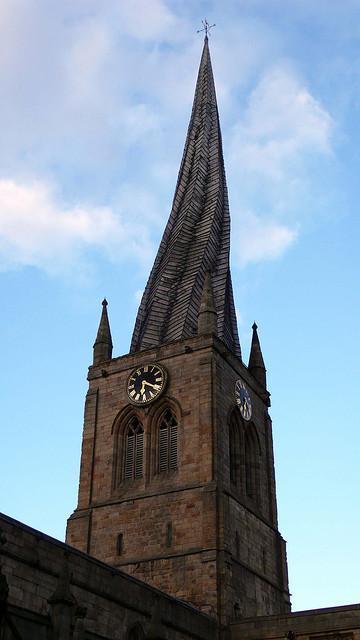How many people are on the white yacht?
Give a very brief answer. 0. 